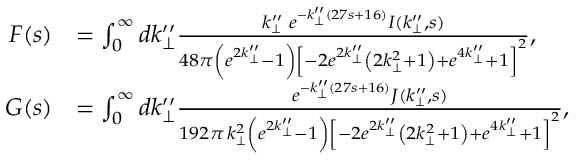<formula> <loc_0><loc_0><loc_500><loc_500>\begin{array} { r l } { F ( s ) } & { = \int _ { 0 } ^ { \infty } d k _ { \perp } ^ { \prime \prime } \frac { k _ { \perp } ^ { \prime \prime } \, e ^ { - k _ { \perp } ^ { \prime \prime } ( 2 7 s + 1 6 ) } I ( k _ { \perp } ^ { \prime \prime } , s ) } { 4 8 \pi \left ( e ^ { 2 k _ { \perp } ^ { \prime \prime } } - 1 \right ) \left [ - 2 e ^ { 2 k _ { \perp } ^ { \prime \prime } } \left ( 2 k _ { \perp } ^ { 2 } + 1 \right ) + e ^ { 4 k _ { \perp } ^ { \prime \prime } } + 1 \right ] ^ { 2 } } , } \\ { G ( s ) } & { = \int _ { 0 } ^ { \infty } d k _ { \perp } ^ { \prime \prime } \frac { e ^ { - k _ { \perp } ^ { \prime \prime } ( 2 7 s + 1 6 ) } J ( k _ { \perp } ^ { \prime \prime } , s ) } { 1 9 2 \pi \, k _ { \perp } ^ { 2 } \left ( e ^ { 2 k _ { \perp } ^ { \prime \prime } } - 1 \right ) \left [ - 2 e ^ { 2 k _ { \perp } ^ { \prime \prime } } \left ( 2 k _ { \perp } ^ { 2 } + 1 \right ) + e ^ { 4 k _ { \perp } ^ { \prime \prime } } + 1 \right ] ^ { 2 } } , } \end{array}</formula> 